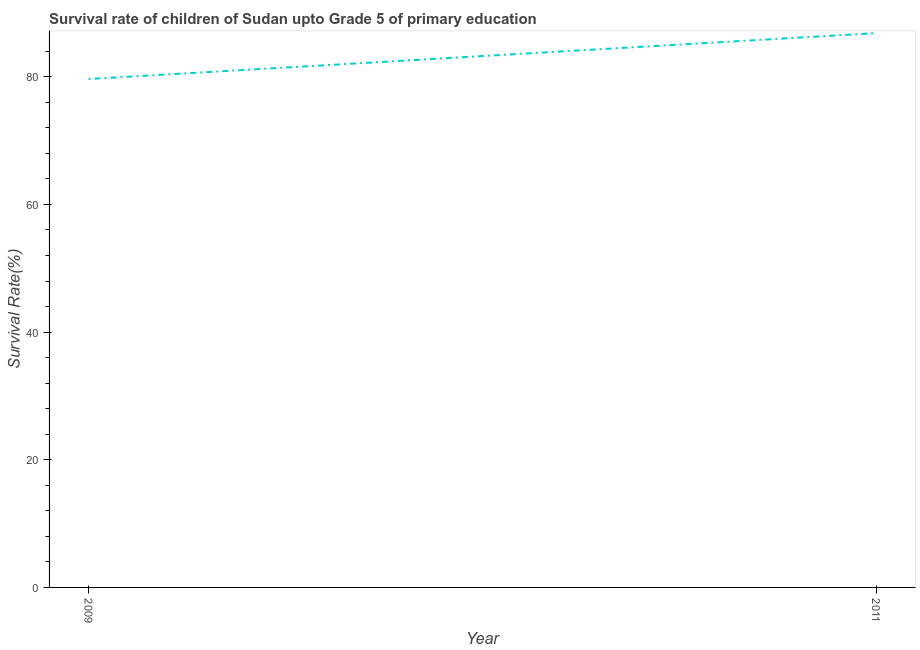What is the survival rate in 2009?
Ensure brevity in your answer.  79.65. Across all years, what is the maximum survival rate?
Offer a very short reply. 86.84. Across all years, what is the minimum survival rate?
Offer a terse response. 79.65. What is the sum of the survival rate?
Offer a terse response. 166.5. What is the difference between the survival rate in 2009 and 2011?
Keep it short and to the point. -7.19. What is the average survival rate per year?
Your answer should be very brief. 83.25. What is the median survival rate?
Give a very brief answer. 83.25. Do a majority of the years between 2009 and 2011 (inclusive) have survival rate greater than 20 %?
Give a very brief answer. Yes. What is the ratio of the survival rate in 2009 to that in 2011?
Your answer should be very brief. 0.92. Is the survival rate in 2009 less than that in 2011?
Keep it short and to the point. Yes. In how many years, is the survival rate greater than the average survival rate taken over all years?
Offer a very short reply. 1. How many years are there in the graph?
Provide a succinct answer. 2. What is the difference between two consecutive major ticks on the Y-axis?
Your answer should be very brief. 20. Are the values on the major ticks of Y-axis written in scientific E-notation?
Provide a short and direct response. No. Does the graph contain grids?
Make the answer very short. No. What is the title of the graph?
Make the answer very short. Survival rate of children of Sudan upto Grade 5 of primary education. What is the label or title of the Y-axis?
Your response must be concise. Survival Rate(%). What is the Survival Rate(%) of 2009?
Offer a very short reply. 79.65. What is the Survival Rate(%) in 2011?
Provide a short and direct response. 86.84. What is the difference between the Survival Rate(%) in 2009 and 2011?
Your response must be concise. -7.19. What is the ratio of the Survival Rate(%) in 2009 to that in 2011?
Your answer should be very brief. 0.92. 